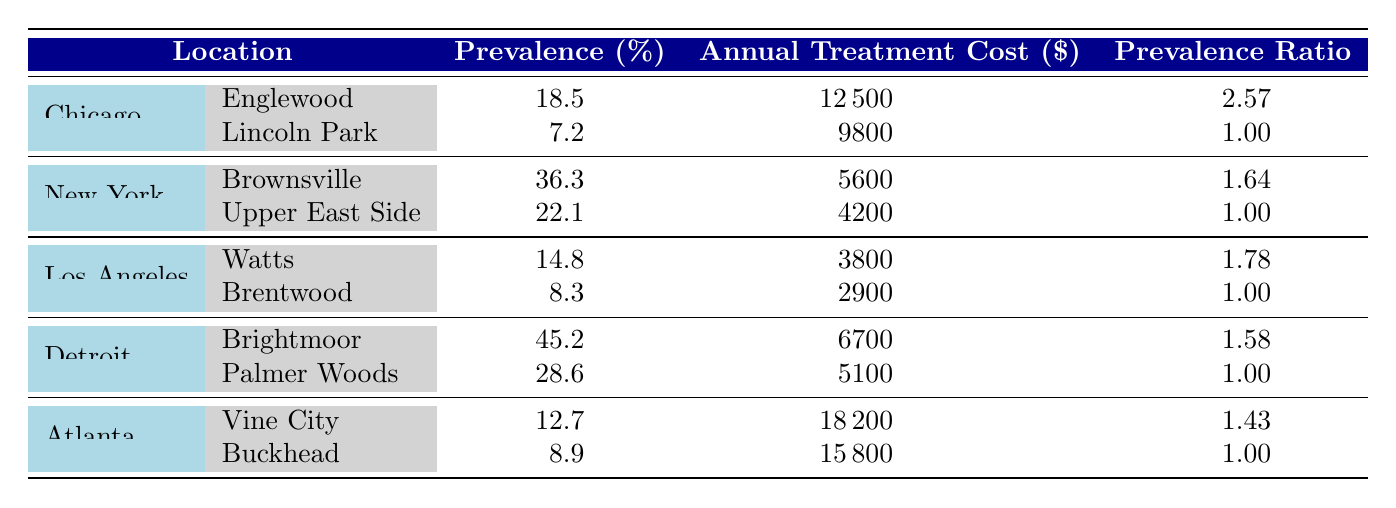What is the prevalence of diabetes in Englewood, Chicago? The table shows that the prevalence of diabetes in Englewood, Chicago is listed directly in the "Prevalence (%)" column next to the neighborhood. It states 18.5%.
Answer: 18.5% Which neighborhood in Los Angeles has the lowest annual treatment cost for asthma? Looking at the "Annual Treatment Cost ($)" column for Los Angeles, Brentwood has an annual treatment cost of 2900, while Watts has a higher cost at 3800. Therefore, Brentwood has the lowest treatment cost.
Answer: Brentwood What is the average treatment cost for obesity in Detroit? The two neighborhoods in Detroit listed for obesity are Brightmoor (6700) and Palmer Woods (5100). Adding these amounts gives 6700 + 5100 = 11800. Dividing by the number of neighborhoods (2) gives an average of 11800 / 2 = 5900.
Answer: 5900 Is the prevalence of hypertension higher in Brownsville than in the Upper East Side? The table shows a prevalence of 36.3% in Brownsville and 22.1% in the Upper East Side. Since 36.3% is greater than 22.1%, it confirms that Brownsville has a higher prevalence of hypertension.
Answer: Yes How much higher is the prevalence of obesity in Brightmoor compared to Palmer Woods? The prevalence for Brightmoor is 45.2% and for Palmer Woods, it is 28.6%. The difference is calculated by subtracting the lower prevalence from the higher one: 45.2% - 28.6% = 16.6%.
Answer: 16.6% What percentage of neighborhoods listed have access to specialists rated as low? There are 10 neighborhoods total and 4 (Englewood, Watts, Brightmoor, and Vine City) have "Low" access to specialists. Therefore, the percentage is (4 / 10) * 100 = 40%.
Answer: 40% Which city has the highest prevalence of any chronic disease among the neighborhoods listed? By reviewing the "Prevalence (%)" column, Brightmoor in Detroit has the highest prevalence at 45.2%. No other neighborhood exceeds this figure. Therefore, Detroit holds the highest prevalence for chronic disease in the listed neighborhoods.
Answer: Detroit Are there more neighborhoods with higher treatment costs for heart disease than for asthma? In the table, the annual treatment costs for heart disease are 18200 (Vine City) and 15800 (Buckhead), while for asthma, they are 3800 (Watts) and 2900 (Brentwood). Both cases provide two neighborhoods for each disease, and since both heart disease costs are significantly higher than the asthma costs, it confirms that there are more neighborhoods with higher treatment costs for heart disease.
Answer: Yes 